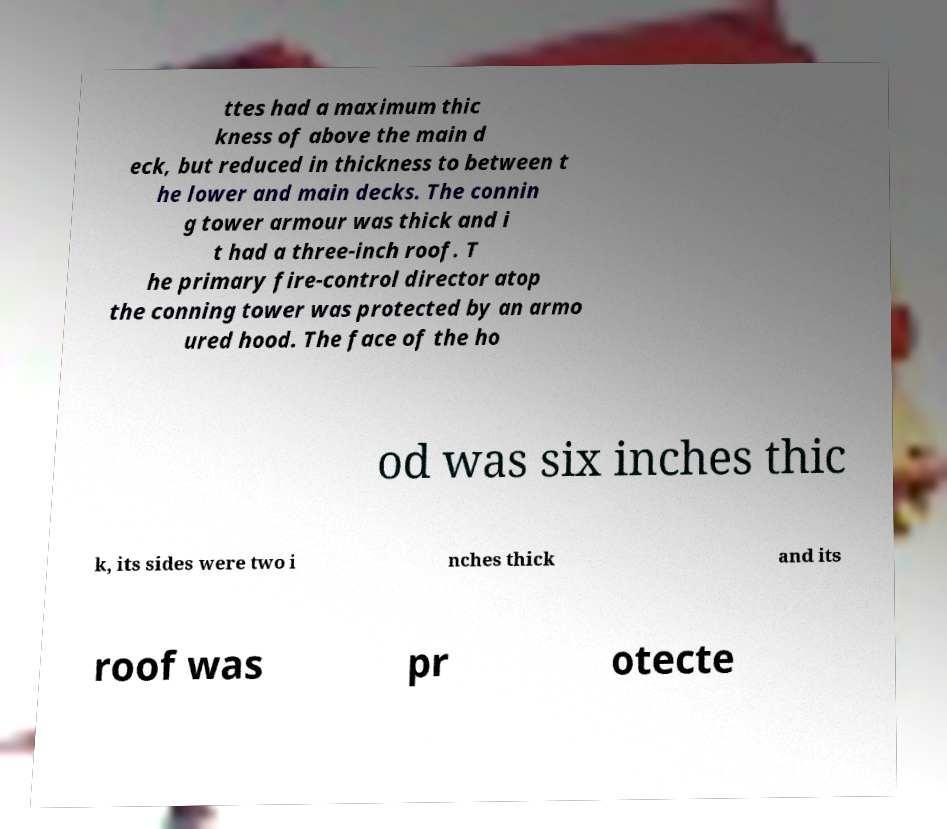Please identify and transcribe the text found in this image. ttes had a maximum thic kness of above the main d eck, but reduced in thickness to between t he lower and main decks. The connin g tower armour was thick and i t had a three-inch roof. T he primary fire-control director atop the conning tower was protected by an armo ured hood. The face of the ho od was six inches thic k, its sides were two i nches thick and its roof was pr otecte 